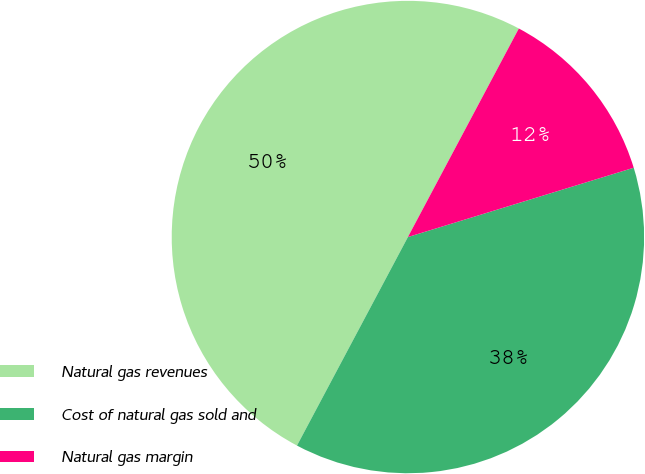Convert chart. <chart><loc_0><loc_0><loc_500><loc_500><pie_chart><fcel>Natural gas revenues<fcel>Cost of natural gas sold and<fcel>Natural gas margin<nl><fcel>50.0%<fcel>37.52%<fcel>12.48%<nl></chart> 